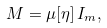<formula> <loc_0><loc_0><loc_500><loc_500>M = \mu [ \eta ] \, I _ { m } ,</formula> 